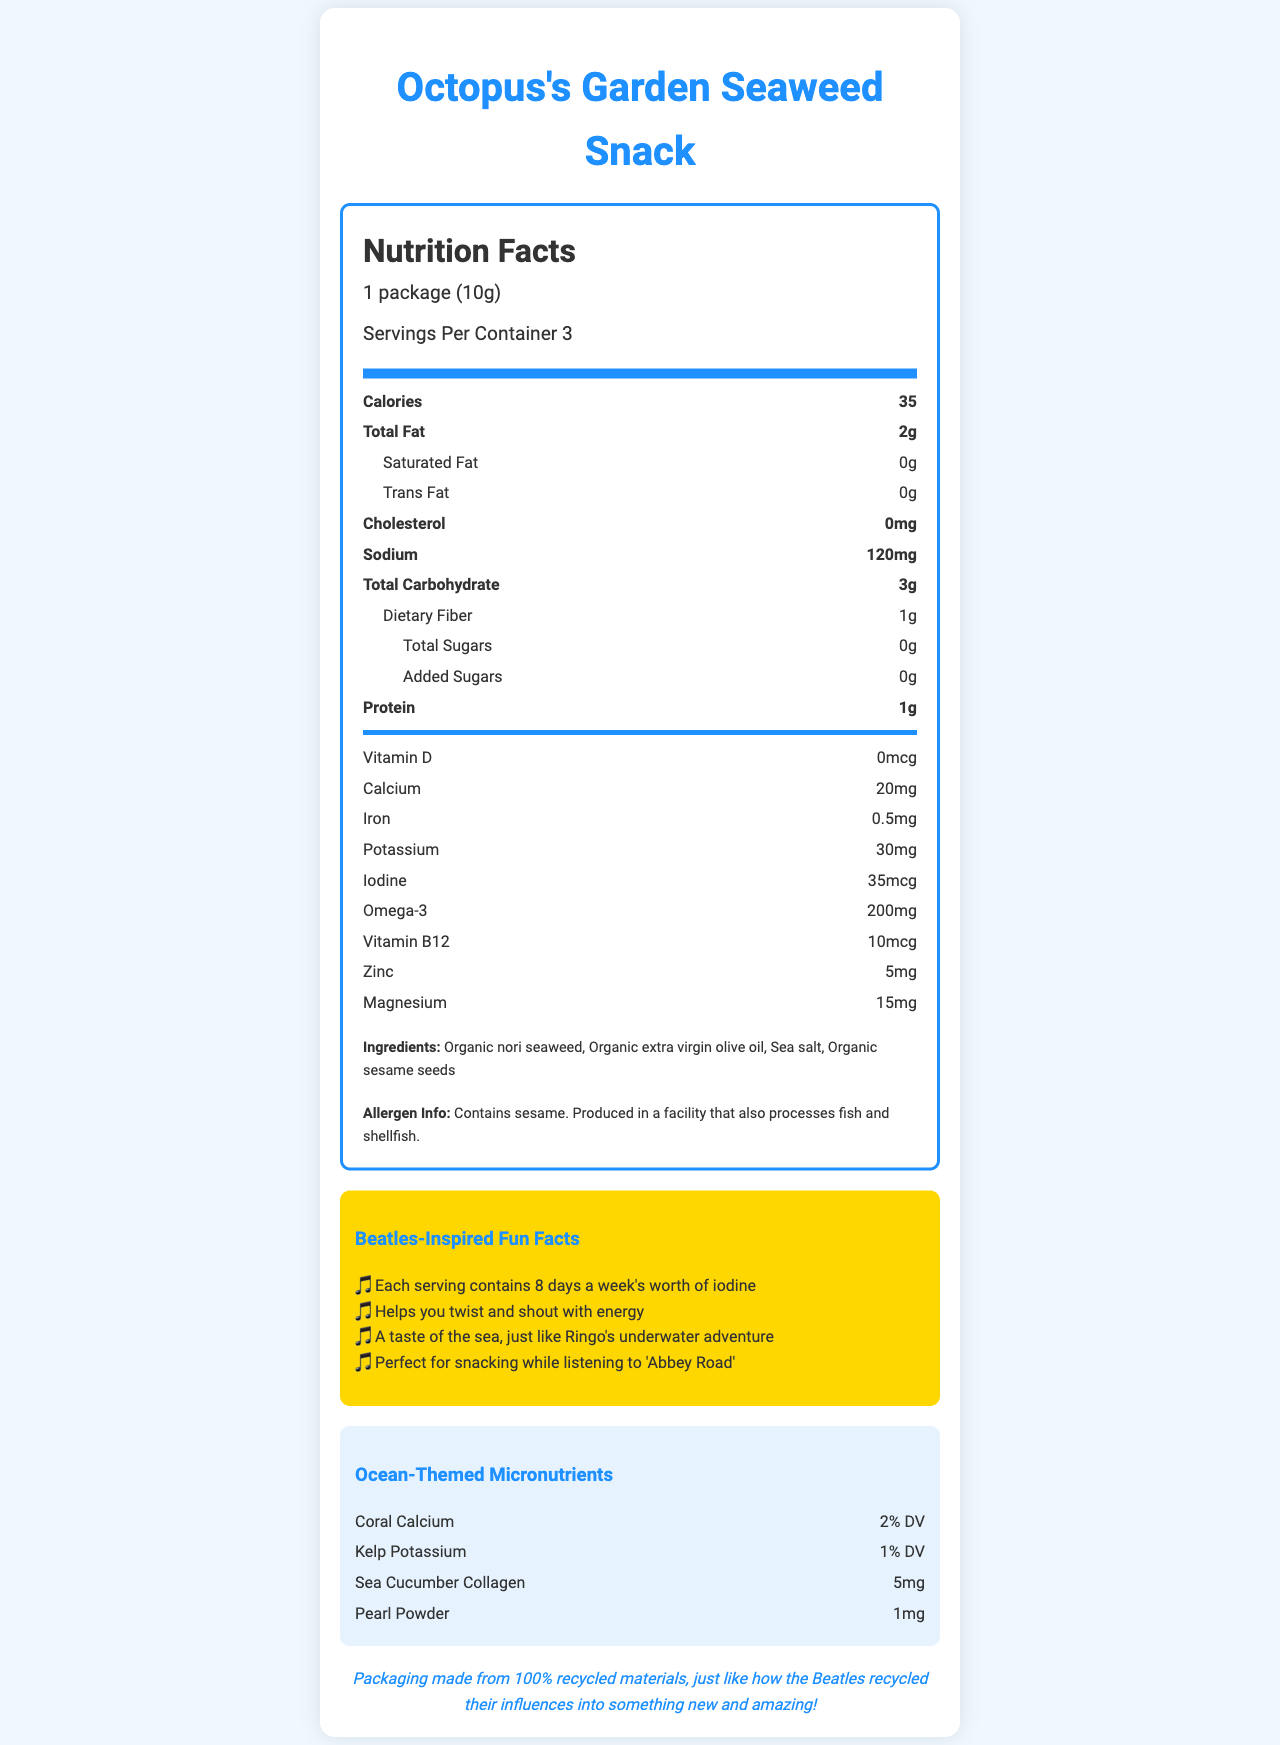what is the serving size for the Octopus's Garden Seaweed Snack? The serving size is listed as "1 package (10g)" under the Nutrition Facts section.
Answer: 1 package (10g) how many calories are in one serving of the seaweed snack? The number of calories per serving is given as 35 in the Nutrition Facts section.
Answer: 35 what is the total fat content per serving? The total fat content per serving is shown as 2g under the Nutrition Facts section.
Answer: 2g how much sodium is in one serving? The sodium content per serving is listed as 120mg in the Nutrition Facts section.
Answer: 120mg how much protein is there in each serving? The protein content per serving is indicated as 1g in the Nutrition Facts section.
Answer: 1g which micronutrient is provided in the highest percentage of daily value (DV) in this snack? Iodine is the micronutrient with the highest percentage of daily value at 8 days a week, as per the Beatles-inspired fact.
Answer: Iodine which ingredient(s) does the seaweed snack contain? A. Organic nori seaweed B. Organic sesame seeds C. Sea salt D. All of the above The ingredients list shows "Organic nori seaweed," "Organic extra virgin olive oil," "Sea salt," and "Organic sesame seeds," covering all the options.
Answer: D. All of the above how many servings are there in the entire container? A. 1 B. 3 C. 5 D. 10 The document states that there are "Servings Per Container 3."
Answer: B. 3 does the product contain sesame? The allergen information states, "Contains sesame."
Answer: Yes is there any cholesterol in the Octopus's Garden Seaweed Snack? The Nutrition Facts section shows 0mg of cholesterol per serving.
Answer: No which of the following is an ocean-themed micronutrient in the snack? A. Sea cucumber collagen B. Coral calcium C. Pearl powder D. All of the above The ocean-themed micronutrients listed are "Coral calcium," "Kelp potassium," "Sea cucumber collagen," and "Pearl powder."
Answer: D. All of the above how is the package designed? The document mentions that the package design is "Yellow Submarine themed."
Answer: Yellow Submarine themed describe the sustainability aspect of the packaging. The sustainability note at the end mentions that "Packaging made from 100% recycled materials."
Answer: The packaging is made from 100% recycled materials. what is the unique shape of the seaweed snacks? The document states that the snacks are "guitar pick-shaped."
Answer: Guitar pick-shaped how much Omega-3 is in each serving? The amount of Omega-3 per serving is listed as 200mg in the Nutrition Facts section.
Answer: 200mg are the snacks recommended for snacking while listening to a specific Beatles album? One of the Beatles-inspired fun facts mentions, "Perfect for snacking while listening to 'Abbey Road'."
Answer: Yes summarize the main idea of the document. The document gives details about the Octopus’s Garden Seaweed Snack including its nutritional content, ingredients, unique packaging design, and supplementary Beatles-inspired fun facts.
Answer: The document provides the nutritional information, ingredients, allergen information, and fun facts for Octopus's Garden Seaweed Snack, highlighting its ocean-themed micronutrients and Beatles-inspired packaging design. what is the primary type of oil used in the seaweed snack? The provided document mentions "Organic extra virgin olive oil," but does not specify if it's the primary type used among other potential oils not listed.
Answer: Cannot be determined what percentage DV of calcium does the snack provide? The nutrition facts show the snack provides 2% of the daily value for calcium.
Answer: 2% DV 